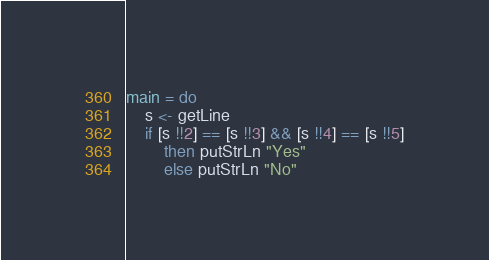Convert code to text. <code><loc_0><loc_0><loc_500><loc_500><_Haskell_>main = do
    s <- getLine
    if [s !!2] == [s !!3] && [s !!4] == [s !!5]
        then putStrLn "Yes"
        else putStrLn "No"</code> 